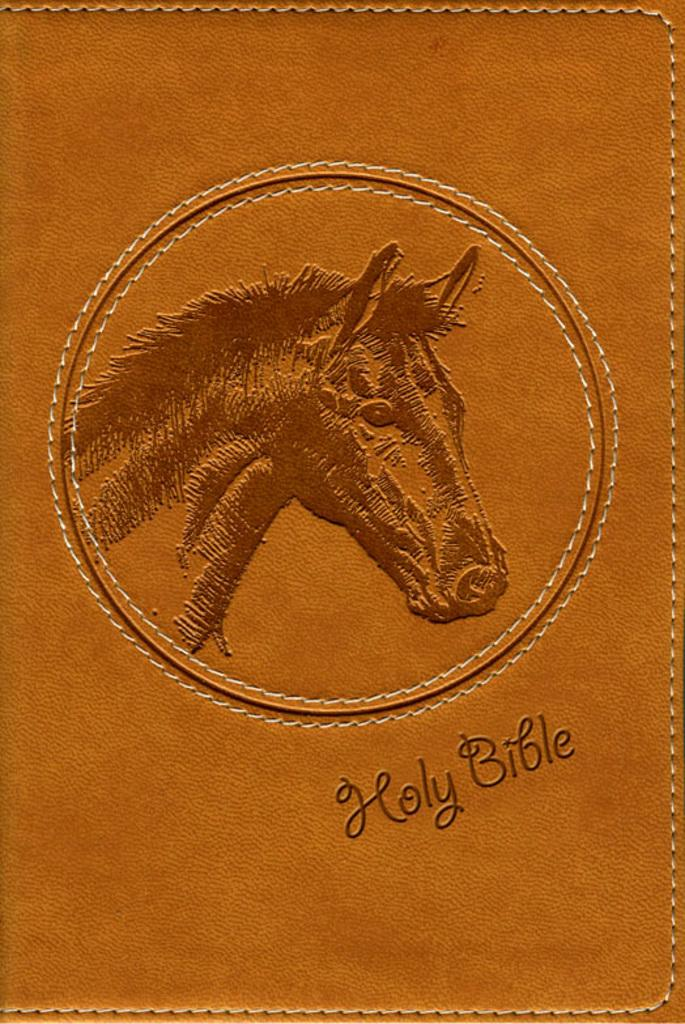What is the main subject of the image? The main subject of the image is a picture of a horse. Is there any text present in the image? Yes, there is text in the image. Reasoning: Let'g: Let's think step by step in order to produce the conversation. We start by identifying the main subject of the image, which is the picture of a horse. Then, we acknowledge the presence of text in the image, as stated in the facts. We avoid yes/no questions and ensure that the language is simple and clear. Absurd Question/Answer: Can you describe the fog surrounding the railway in the image? There is no fog or railway present in the image; it features a picture of a horse and text. How does the growth of the plants affect the railway in the image? There is no railway or plants present in the image; it features a picture of a horse and text. 